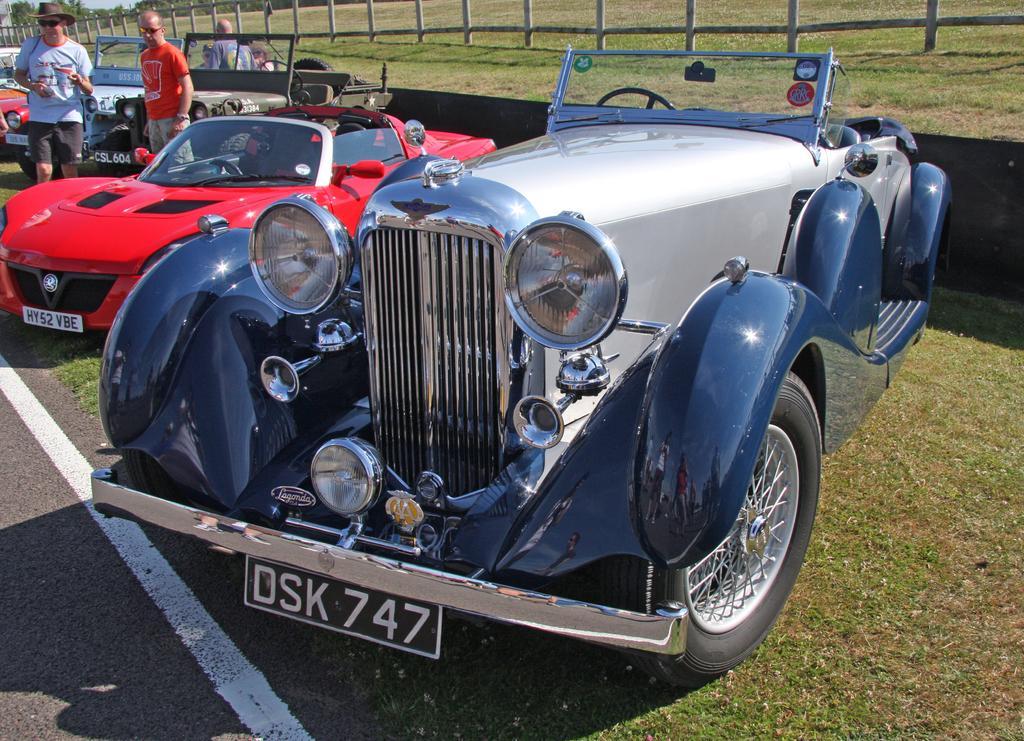In one or two sentences, can you explain what this image depicts? In this picture we can observe some cars and jeeps parked on the ground. We can observe a road on the left side. There are blue and red color cars here. In the background there are poles. We can observe some people on the left side. 